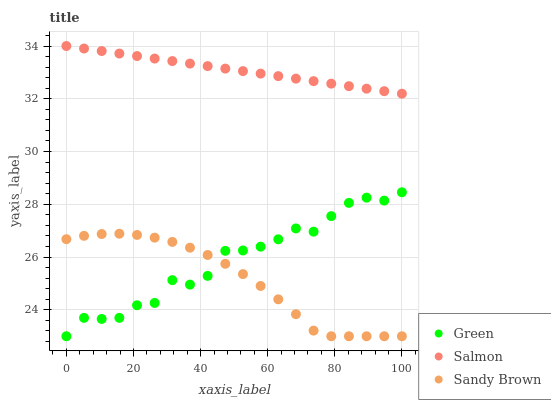Does Sandy Brown have the minimum area under the curve?
Answer yes or no. Yes. Does Salmon have the maximum area under the curve?
Answer yes or no. Yes. Does Green have the minimum area under the curve?
Answer yes or no. No. Does Green have the maximum area under the curve?
Answer yes or no. No. Is Salmon the smoothest?
Answer yes or no. Yes. Is Green the roughest?
Answer yes or no. Yes. Is Sandy Brown the smoothest?
Answer yes or no. No. Is Sandy Brown the roughest?
Answer yes or no. No. Does Green have the lowest value?
Answer yes or no. Yes. Does Salmon have the highest value?
Answer yes or no. Yes. Does Green have the highest value?
Answer yes or no. No. Is Green less than Salmon?
Answer yes or no. Yes. Is Salmon greater than Green?
Answer yes or no. Yes. Does Sandy Brown intersect Green?
Answer yes or no. Yes. Is Sandy Brown less than Green?
Answer yes or no. No. Is Sandy Brown greater than Green?
Answer yes or no. No. Does Green intersect Salmon?
Answer yes or no. No. 